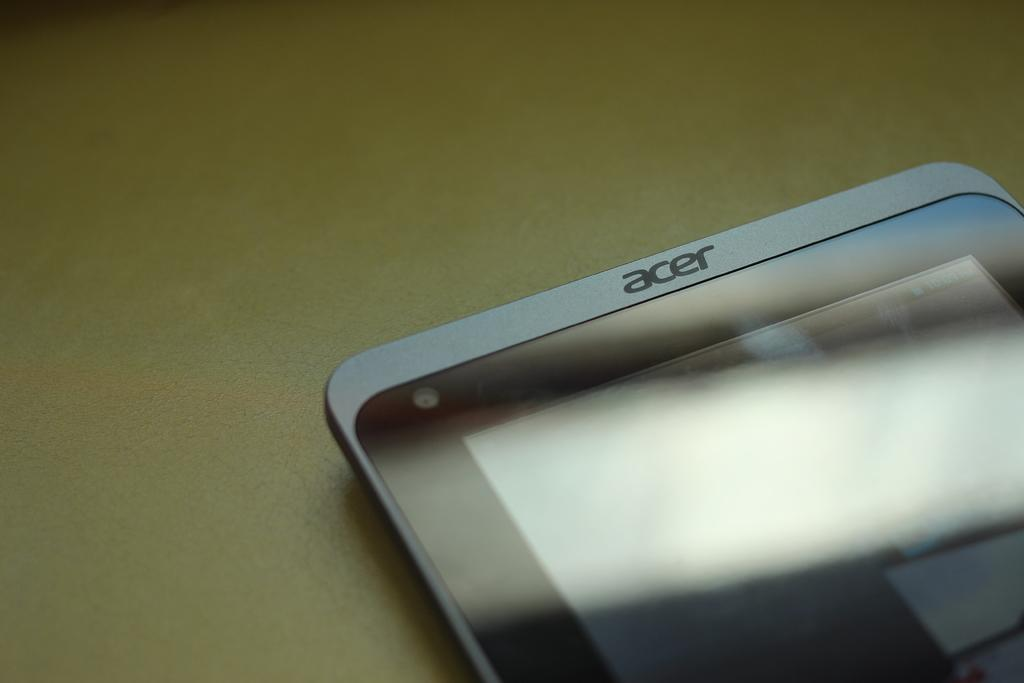Provide a one-sentence caption for the provided image. An aesthetic advertisement image of an acer phone. 